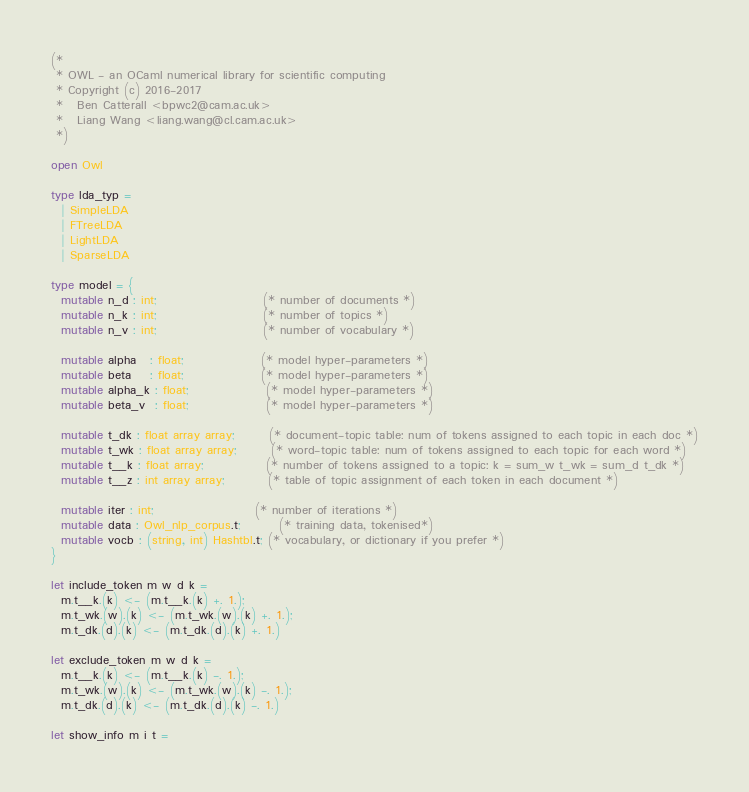Convert code to text. <code><loc_0><loc_0><loc_500><loc_500><_OCaml_>(*
 * OWL - an OCaml numerical library for scientific computing
 * Copyright (c) 2016-2017
 *   Ben Catterall <bpwc2@cam.ac.uk>
 *   Liang Wang <liang.wang@cl.cam.ac.uk>
 *)

open Owl

type lda_typ =
  | SimpleLDA
  | FTreeLDA
  | LightLDA
  | SparseLDA

type model = {
  mutable n_d : int;                      (* number of documents *)
  mutable n_k : int;                      (* number of topics *)
  mutable n_v : int;                      (* number of vocabulary *)

  mutable alpha   : float;                (* model hyper-parameters *)
  mutable beta    : float;                (* model hyper-parameters *)
  mutable alpha_k : float;                (* model hyper-parameters *)
  mutable beta_v  : float;                (* model hyper-parameters *)

  mutable t_dk : float array array;       (* document-topic table: num of tokens assigned to each topic in each doc *)
  mutable t_wk : float array array;       (* word-topic table: num of tokens assigned to each topic for each word *)
  mutable t__k : float array;             (* number of tokens assigned to a topic: k = sum_w t_wk = sum_d t_dk *)
  mutable t__z : int array array;         (* table of topic assignment of each token in each document *)

  mutable iter : int;                     (* number of iterations *)
  mutable data : Owl_nlp_corpus.t;        (* training data, tokenised*)
  mutable vocb : (string, int) Hashtbl.t; (* vocabulary, or dictionary if you prefer *)
}

let include_token m w d k =
  m.t__k.(k) <- (m.t__k.(k) +. 1.);
  m.t_wk.(w).(k) <- (m.t_wk.(w).(k) +. 1.);
  m.t_dk.(d).(k) <- (m.t_dk.(d).(k) +. 1.)

let exclude_token m w d k =
  m.t__k.(k) <- (m.t__k.(k) -. 1.);
  m.t_wk.(w).(k) <- (m.t_wk.(w).(k) -. 1.);
  m.t_dk.(d).(k) <- (m.t_dk.(d).(k) -. 1.)

let show_info m i t =</code> 